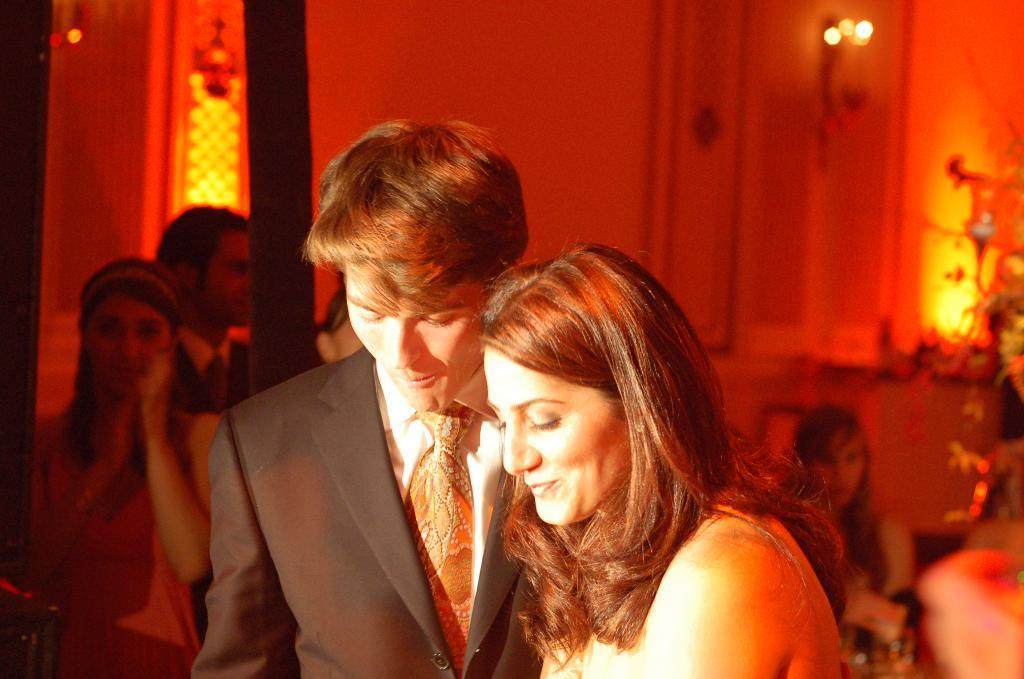What is the man in the image wearing? The man in the image is wearing a white shirt and a black blazer. Who is standing beside the man? There is a woman standing beside the man. Can you describe the background of the image? There are other persons, a wall, and lights visible in the background of the image. What type of paste is being used by the man to measure the selection of items in the image? There is no paste or selection of items present in the image. 